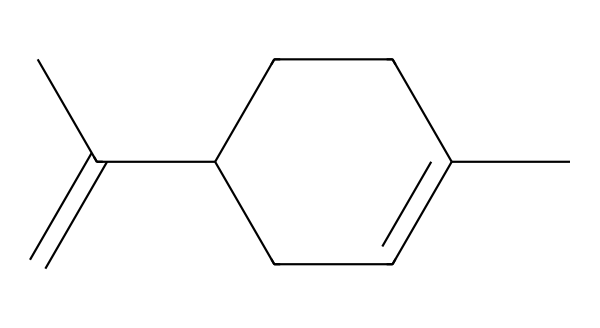What is the molecular formula of limonene? To determine the molecular formula from the SMILES representation, we deconstruct it into its constituent atoms, counting each type. From the given SMILES, we can deduce that there are 10 carbon atoms (C) and 16 hydrogen atoms (H), thus the formula is C10H16.
Answer: C10H16 How many double bonds are present in limonene? Inspecting the structure, we can identify the locations of double bonds by evaluating the connections in the SMILES. There are two instances in the structure where carbon atoms are connected by a double bond, indicating that there are 2 double bonds in total.
Answer: 2 What type of compound is limonene classified as? Based on its structure and functional groups, limonene contains carbon and hydrogen, and does not have oxygen or nitrogen. Given this, it is classified as a terpene, more specifically a monoterpene due to its 10 carbon atoms.
Answer: terpene How many cyclic structures are in limonene? Analyzing the structure, we see that it contains one cycloalkane ring (the ring formed by the carbon atoms). This indicates that there is 1 cyclic structure in limonene.
Answer: 1 Does limonene have any functional groups? A detailed inspection of the SMILES reveals that limonene has no additional functional groups like alcohols or ketones; it consists mainly of a hydrocarbon framework. Therefore, it doesn’t contain any functional groups.
Answer: no What is the significance of the carbon backbone in limonene? The carbon backbone in limonene is crucial because it determines the molecular stability and influences its reactivity and properties, such as its volatility and aroma characteristics in scented applications.
Answer: stability and aroma Is limonene a polar or non-polar solvent? Limonene, being a hydrocarbon with no polar functional groups, is generally classified as non-polar, which makes it suitable for dissolving non-polar substances.
Answer: non-polar 